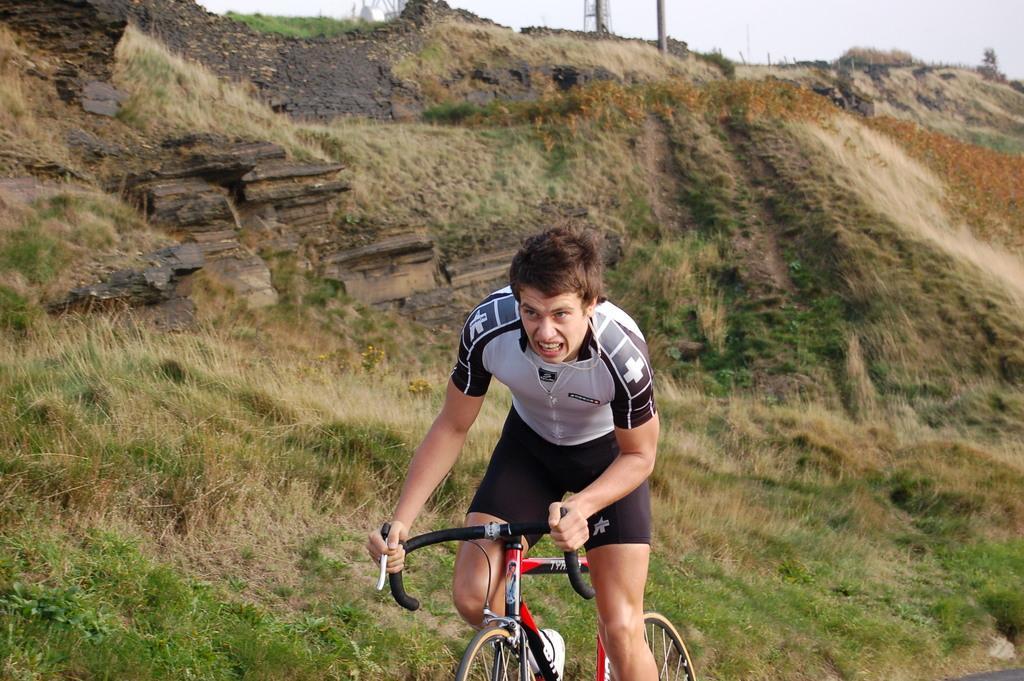Describe this image in one or two sentences. The picture is taken in a hilly area. In the middle one man is riding bicycle. he is wearing black shorts and white t shirt. In the background we can see hill. In the ground there are grasses and shrub. The sky is clear. 